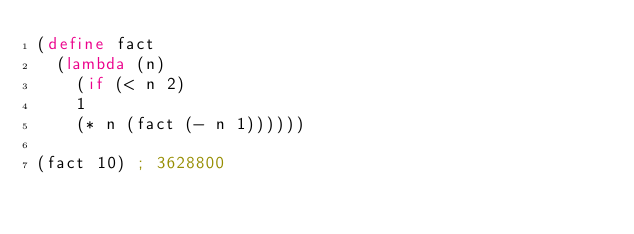<code> <loc_0><loc_0><loc_500><loc_500><_Scheme_>(define fact
  (lambda (n)
    (if (< n 2)
	1
	(* n (fact (- n 1))))))

(fact 10) ; 3628800
</code> 